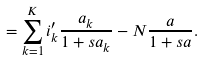<formula> <loc_0><loc_0><loc_500><loc_500>= \sum _ { k = 1 } ^ { K } i _ { k } ^ { \prime } \frac { a _ { k } } { 1 + s a _ { k } } - N \frac { a } { 1 + s a } .</formula> 